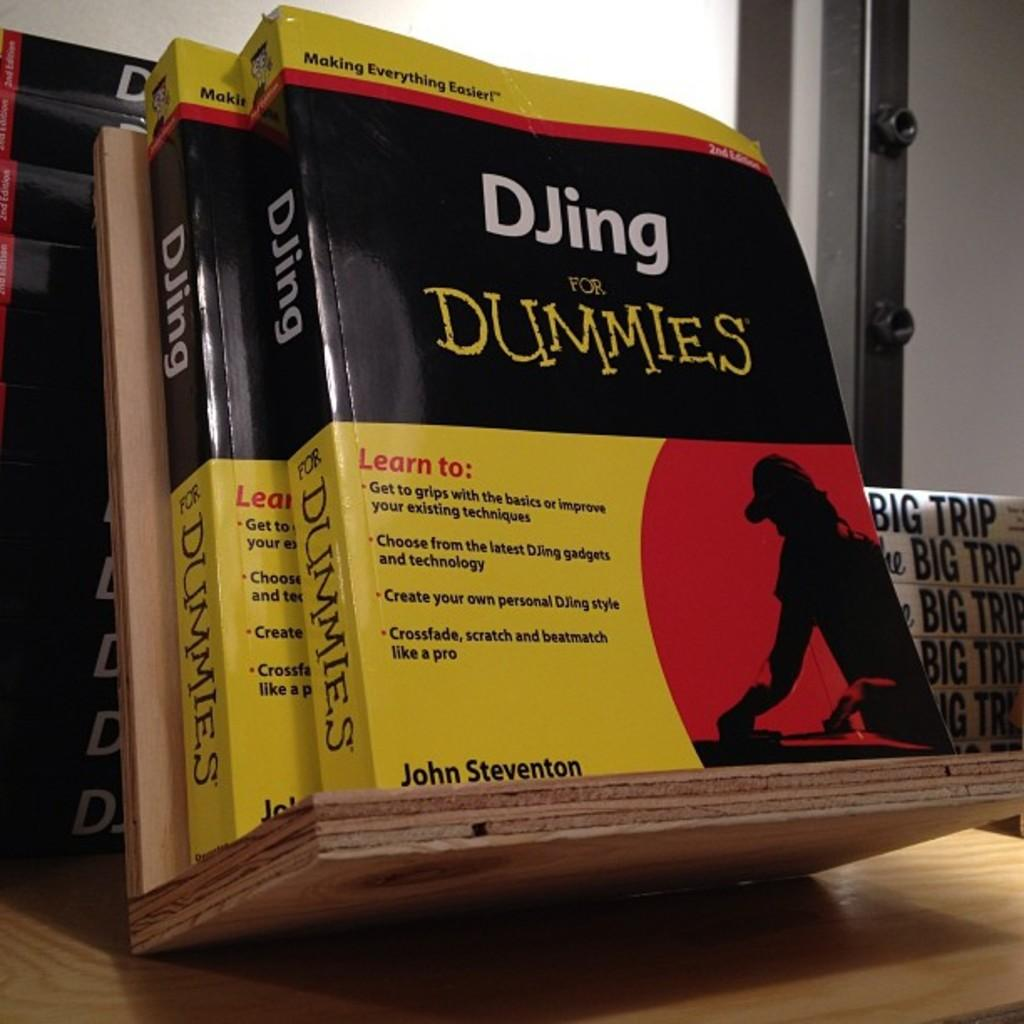What type of furniture is present in the image? There is a table in the image. What can be found on the table in the image? There are books with text written on them in the image. What is visible in the background of the image? There is a wall visible in the background of the image. What type of reward can be seen on the table in the image? There is no reward present on the table in the image; it only contains books. 